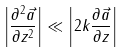<formula> <loc_0><loc_0><loc_500><loc_500>\left | \frac { \partial ^ { 2 } \vec { a } } { \partial z ^ { 2 } } \right | \ll \left | 2 k \frac { \partial \vec { a } } { \partial z } \right |</formula> 